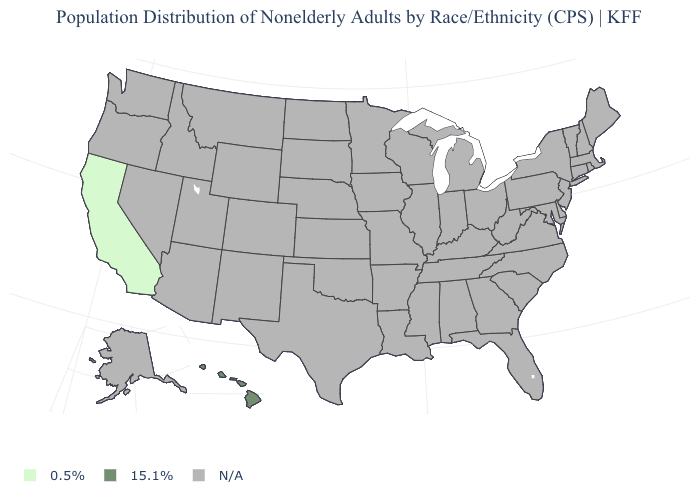Name the states that have a value in the range 0.5%?
Give a very brief answer. California. How many symbols are there in the legend?
Answer briefly. 3. What is the value of Utah?
Short answer required. N/A. Does the map have missing data?
Be succinct. Yes. What is the value of Wyoming?
Write a very short answer. N/A. Name the states that have a value in the range N/A?
Answer briefly. Alabama, Alaska, Arizona, Arkansas, Colorado, Connecticut, Delaware, Florida, Georgia, Idaho, Illinois, Indiana, Iowa, Kansas, Kentucky, Louisiana, Maine, Maryland, Massachusetts, Michigan, Minnesota, Mississippi, Missouri, Montana, Nebraska, Nevada, New Hampshire, New Jersey, New Mexico, New York, North Carolina, North Dakota, Ohio, Oklahoma, Oregon, Pennsylvania, Rhode Island, South Carolina, South Dakota, Tennessee, Texas, Utah, Vermont, Virginia, Washington, West Virginia, Wisconsin, Wyoming. What is the lowest value in the USA?
Be succinct. 0.5%. What is the lowest value in the USA?
Short answer required. 0.5%. Name the states that have a value in the range 0.5%?
Short answer required. California. Does California have the lowest value in the USA?
Short answer required. Yes. Name the states that have a value in the range 0.5%?
Be succinct. California. What is the highest value in the USA?
Be succinct. 15.1%. 